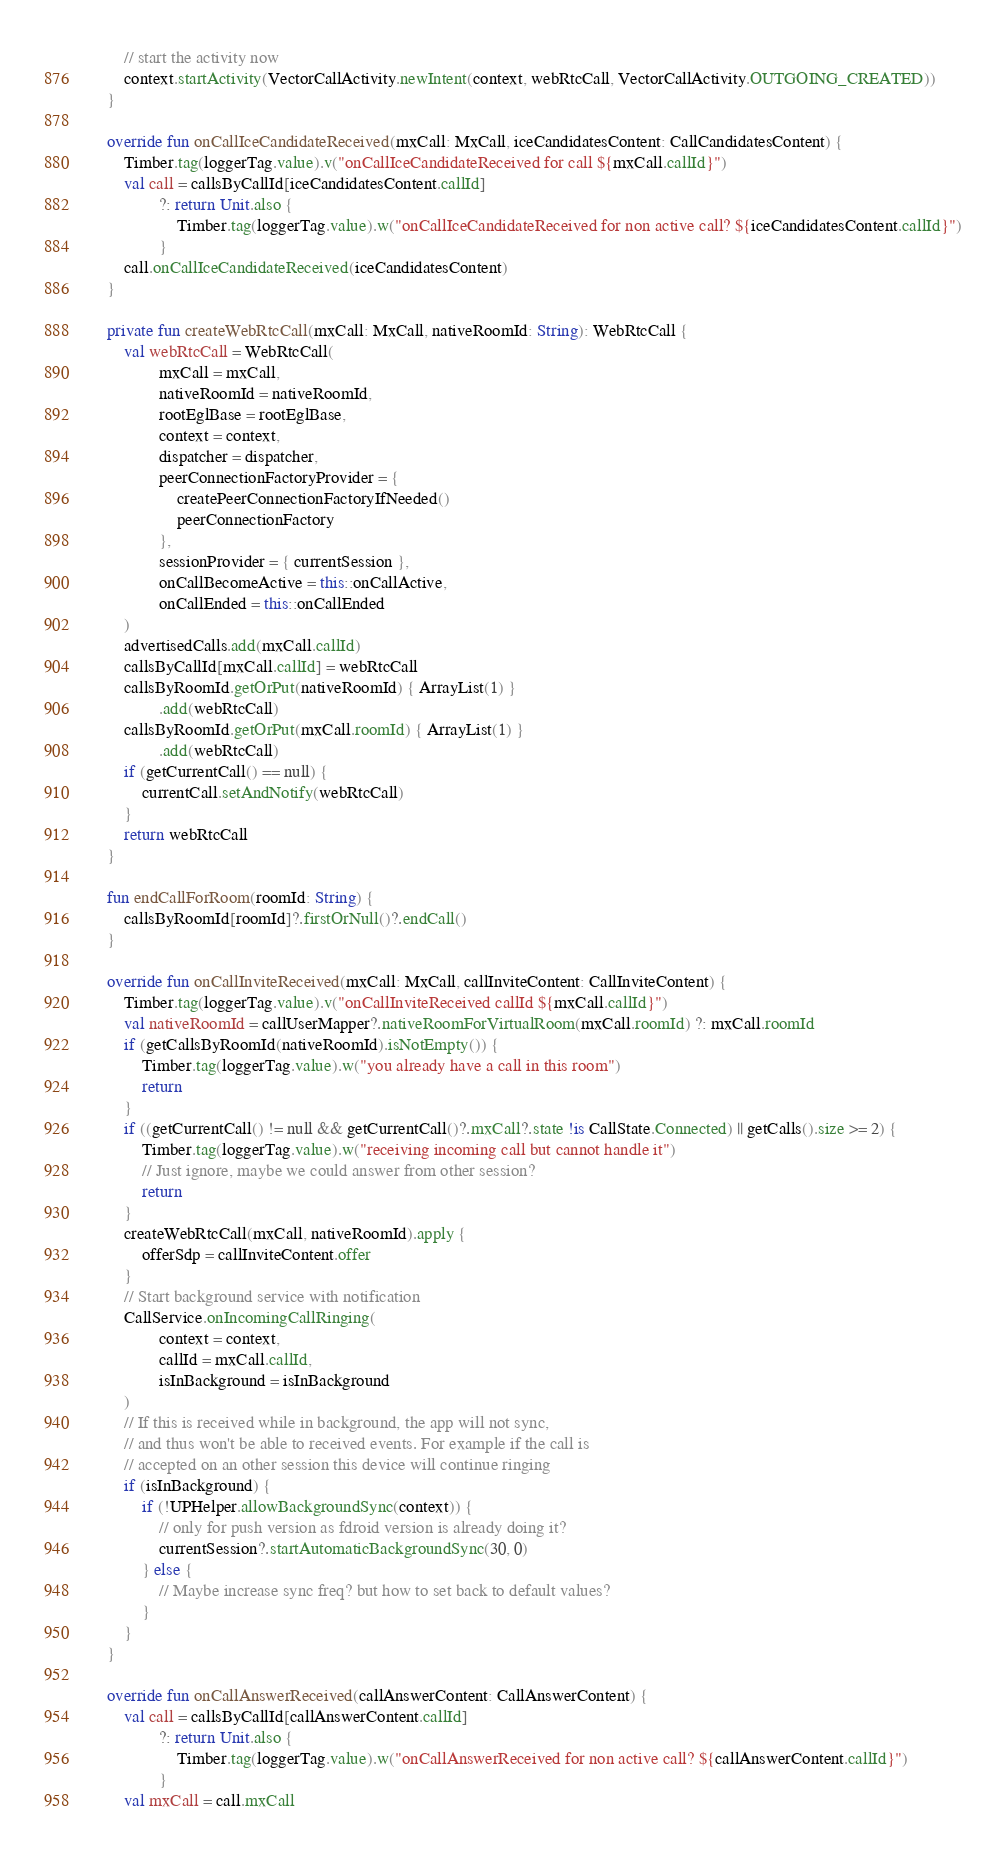Convert code to text. <code><loc_0><loc_0><loc_500><loc_500><_Kotlin_>        // start the activity now
        context.startActivity(VectorCallActivity.newIntent(context, webRtcCall, VectorCallActivity.OUTGOING_CREATED))
    }

    override fun onCallIceCandidateReceived(mxCall: MxCall, iceCandidatesContent: CallCandidatesContent) {
        Timber.tag(loggerTag.value).v("onCallIceCandidateReceived for call ${mxCall.callId}")
        val call = callsByCallId[iceCandidatesContent.callId]
                ?: return Unit.also {
                    Timber.tag(loggerTag.value).w("onCallIceCandidateReceived for non active call? ${iceCandidatesContent.callId}")
                }
        call.onCallIceCandidateReceived(iceCandidatesContent)
    }

    private fun createWebRtcCall(mxCall: MxCall, nativeRoomId: String): WebRtcCall {
        val webRtcCall = WebRtcCall(
                mxCall = mxCall,
                nativeRoomId = nativeRoomId,
                rootEglBase = rootEglBase,
                context = context,
                dispatcher = dispatcher,
                peerConnectionFactoryProvider = {
                    createPeerConnectionFactoryIfNeeded()
                    peerConnectionFactory
                },
                sessionProvider = { currentSession },
                onCallBecomeActive = this::onCallActive,
                onCallEnded = this::onCallEnded
        )
        advertisedCalls.add(mxCall.callId)
        callsByCallId[mxCall.callId] = webRtcCall
        callsByRoomId.getOrPut(nativeRoomId) { ArrayList(1) }
                .add(webRtcCall)
        callsByRoomId.getOrPut(mxCall.roomId) { ArrayList(1) }
                .add(webRtcCall)
        if (getCurrentCall() == null) {
            currentCall.setAndNotify(webRtcCall)
        }
        return webRtcCall
    }

    fun endCallForRoom(roomId: String) {
        callsByRoomId[roomId]?.firstOrNull()?.endCall()
    }

    override fun onCallInviteReceived(mxCall: MxCall, callInviteContent: CallInviteContent) {
        Timber.tag(loggerTag.value).v("onCallInviteReceived callId ${mxCall.callId}")
        val nativeRoomId = callUserMapper?.nativeRoomForVirtualRoom(mxCall.roomId) ?: mxCall.roomId
        if (getCallsByRoomId(nativeRoomId).isNotEmpty()) {
            Timber.tag(loggerTag.value).w("you already have a call in this room")
            return
        }
        if ((getCurrentCall() != null && getCurrentCall()?.mxCall?.state !is CallState.Connected) || getCalls().size >= 2) {
            Timber.tag(loggerTag.value).w("receiving incoming call but cannot handle it")
            // Just ignore, maybe we could answer from other session?
            return
        }
        createWebRtcCall(mxCall, nativeRoomId).apply {
            offerSdp = callInviteContent.offer
        }
        // Start background service with notification
        CallService.onIncomingCallRinging(
                context = context,
                callId = mxCall.callId,
                isInBackground = isInBackground
        )
        // If this is received while in background, the app will not sync,
        // and thus won't be able to received events. For example if the call is
        // accepted on an other session this device will continue ringing
        if (isInBackground) {
            if (!UPHelper.allowBackgroundSync(context)) {
                // only for push version as fdroid version is already doing it?
                currentSession?.startAutomaticBackgroundSync(30, 0)
            } else {
                // Maybe increase sync freq? but how to set back to default values?
            }
        }
    }

    override fun onCallAnswerReceived(callAnswerContent: CallAnswerContent) {
        val call = callsByCallId[callAnswerContent.callId]
                ?: return Unit.also {
                    Timber.tag(loggerTag.value).w("onCallAnswerReceived for non active call? ${callAnswerContent.callId}")
                }
        val mxCall = call.mxCall</code> 